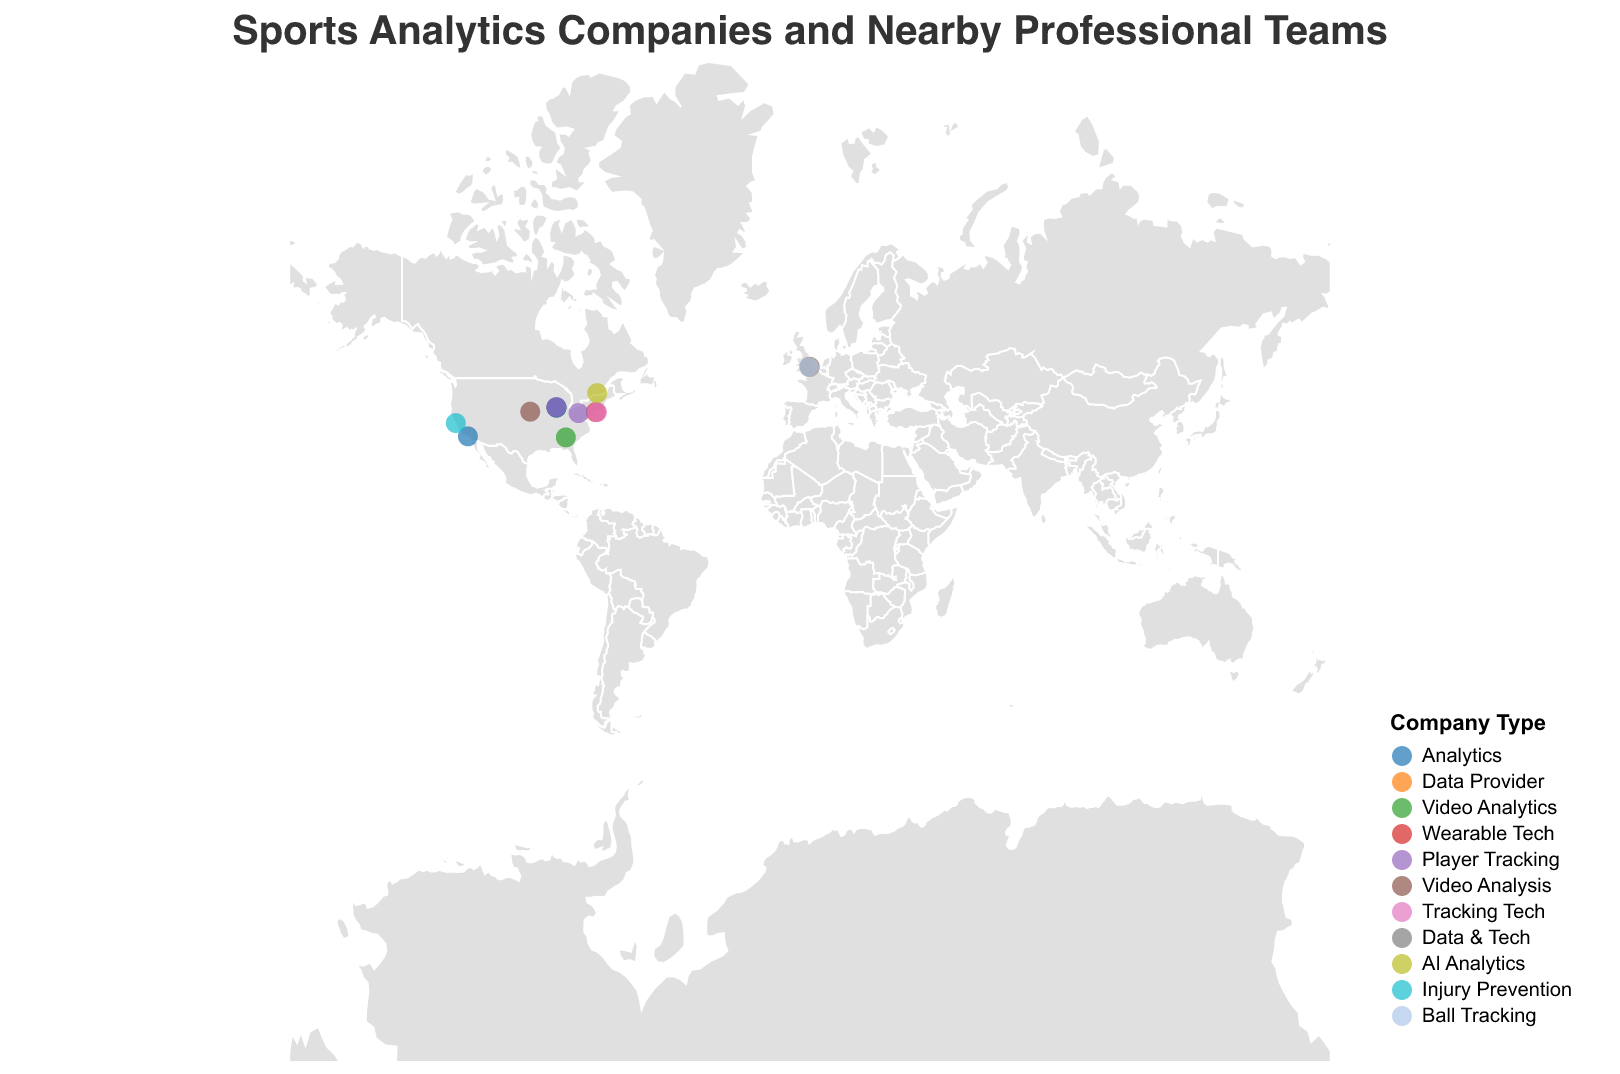How many sports analytics companies are mapped in the figure? Count the total number of data points (circles) on the map. Each circle represents one sports analytics company.
Answer: 15 Which city has the most sports analytics companies nearby professional teams? Identify the city coordinates that have the most circles. From the figure, Chicago has multiple companies including Sportradar, Stats Perform, STATS LLC, and Zebra Technologies.
Answer: Chicago What types of companies are located in the United Kingdom? Look for the circles located in the UK (London and Wimbledon) and check their colors and the tooltip information. In the UK, there are Opta (Data Provider), Genius Sports (Data & Tech), and Hawk-Eye Innovations (Ball Tracking).
Answer: Data Provider, Data & Tech, Ball Tracking How many different types of sports analytics companies are there in total? Refer to the legend to count how many unique types are listed. The legend shows 11 different types of companies.
Answer: 11 Which sports analytics company is closest to the Los Angeles Lakers? Locate the circle representing the Los Angeles Lakers in Los Angeles and refer to the tooltip for company information. The nearby company is Second Spectrum.
Answer: Second Spectrum If a new analytics company is to be established and it needs to be near an NFL team, which city should it consider, based on current trends? Look at the cities with NFL teams and see where current analytics companies are clustered. Chicago has multiple companies, and other significant locations include San Francisco (Kitman Labs) and Pittsburgh (Kinexon).
Answer: Chicago What type of company focuses on 'Injury Prevention' and which professional team is it near? Identify the color corresponding to 'Injury Prevention' from the legend and locate the circle on the map. The company is Kitman Labs near the San Francisco 49ers.
Answer: Kitman Labs, San Francisco 49ers Is there a concentration of any particular type of sports analytics companies in a specific region? Observing the colors and types of companies across the geographic plot, the Analytics type appears concentrated in Chicago (Stats Perform, STATS LLC) and Los Angeles (Second Spectrum).
Answer: Analytics in Chicago and Los Angeles Which European country hosts sports analytics companies related to AI and Data & Tech? Locate the circles in Europe, specifically in the UK (London) and Montreal (Canada). We find Sportlogiq (AI Analytics) in Montreal, Genius Sports (Data & Tech) in London.
Answer: London and Montreal 